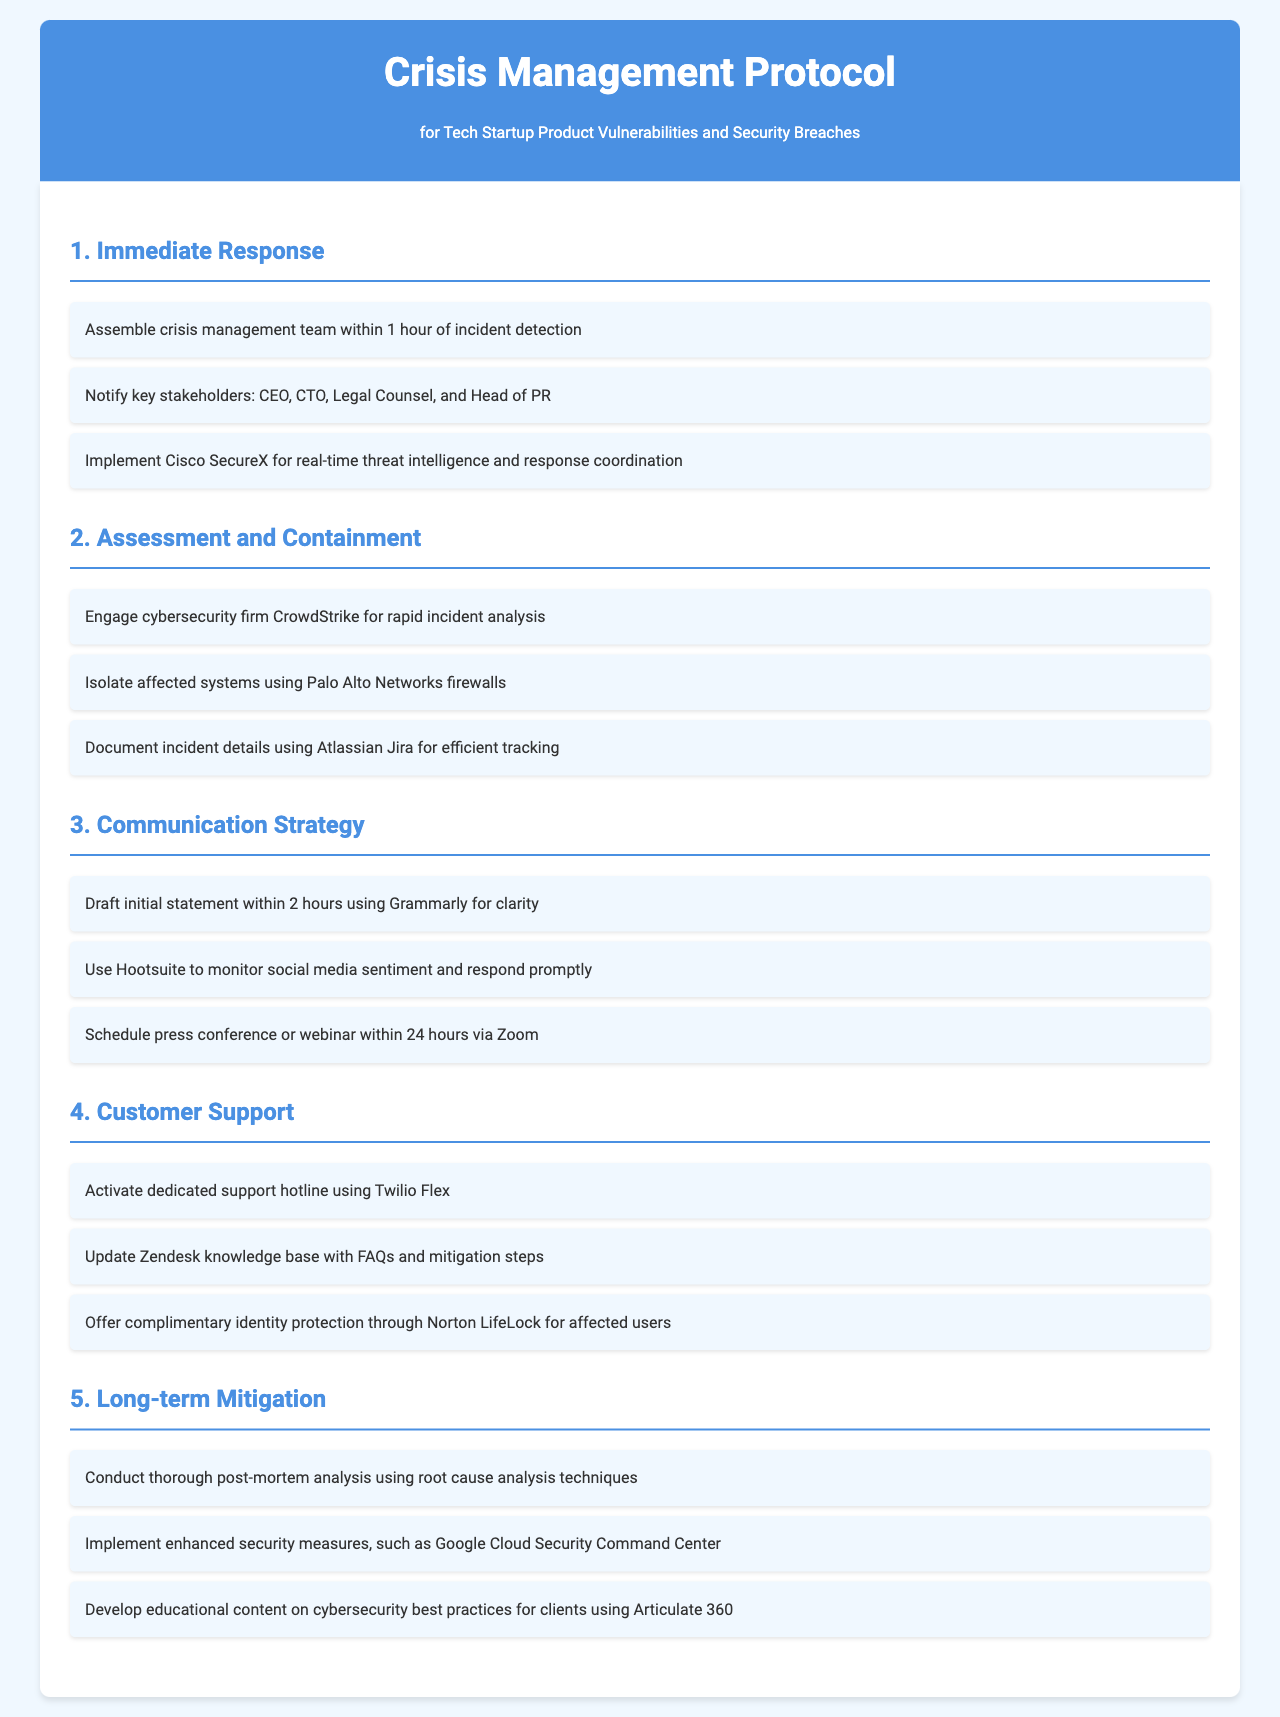What is the time frame to assemble the crisis management team? The document states that the crisis management team should be assembled within 1 hour of incident detection.
Answer: 1 hour Which cybersecurity firm is engaged for rapid incident analysis? The document mentions that CrowdStrike is the cybersecurity firm engaged for rapid incident analysis.
Answer: CrowdStrike What tool is used for tracking incident details? The document specifies that Atlassian Jira is used for documenting incident details.
Answer: Atlassian Jira How soon should the initial communication statement be drafted? According to the document, the initial statement should be drafted within 2 hours.
Answer: 2 hours What service is offered for complimentary identity protection? The document states that Norton LifeLock is offered for complimentary identity protection for affected users.
Answer: Norton LifeLock What platform is suggested for monitoring social media sentiment? The document recommends using Hootsuite to monitor social media sentiment.
Answer: Hootsuite What is the purpose of conducting a post-mortem analysis? The document implies that post-mortem analysis is conducted to understand the root cause of the incident.
Answer: Root cause analysis What type of hotline is activated for customer support? The document indicates that a dedicated support hotline is activated using Twilio Flex.
Answer: Twilio Flex What is scheduled within 24 hours after the incident? The document states that a press conference or webinar is scheduled within 24 hours.
Answer: Press conference or webinar 